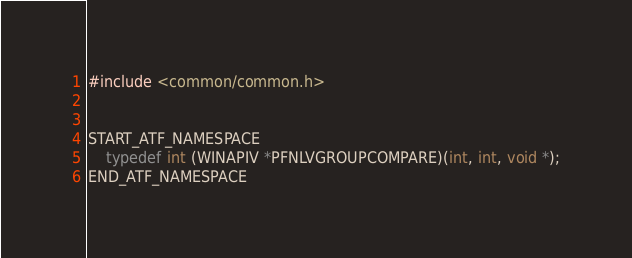Convert code to text. <code><loc_0><loc_0><loc_500><loc_500><_C++_>
#include <common/common.h>


START_ATF_NAMESPACE
    typedef int (WINAPIV *PFNLVGROUPCOMPARE)(int, int, void *);
END_ATF_NAMESPACE
</code> 